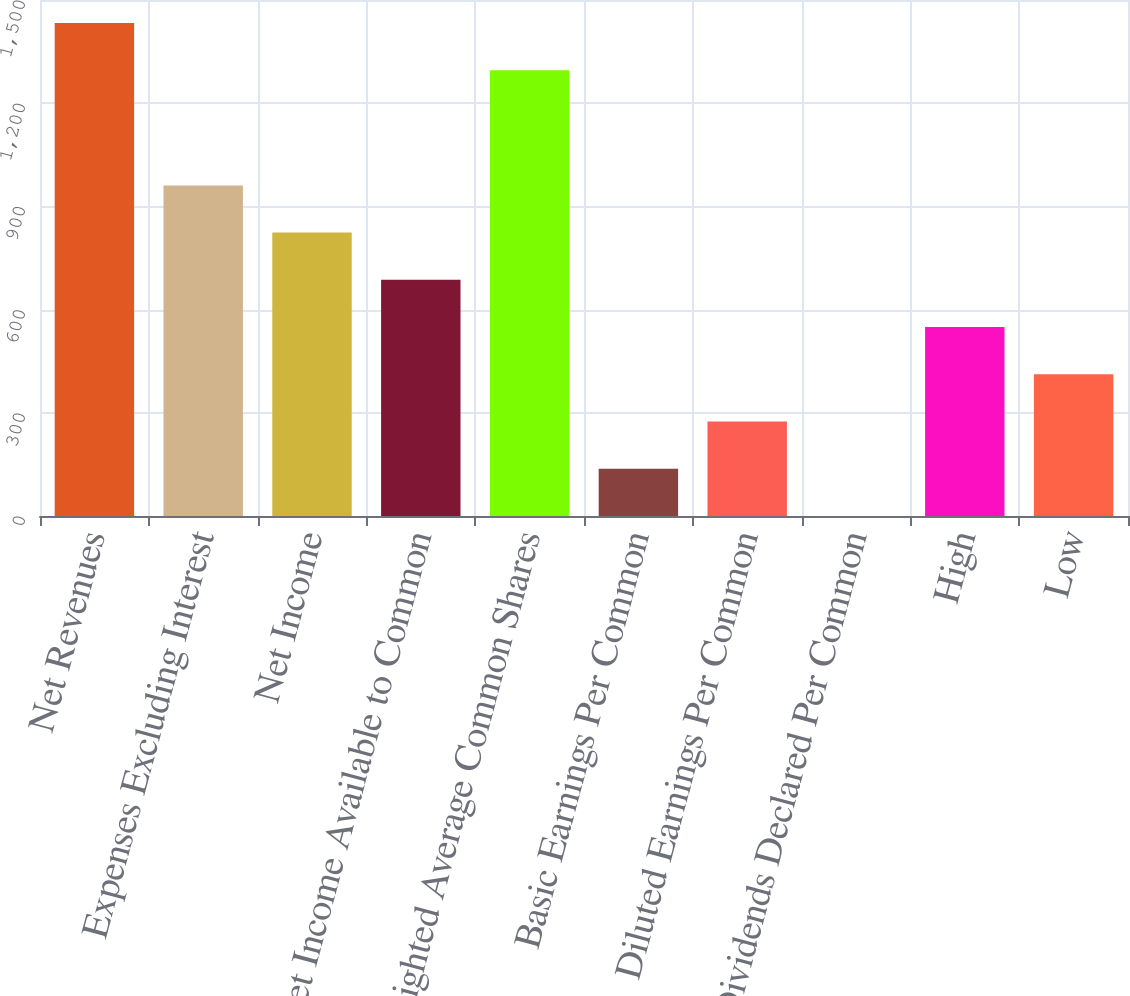Convert chart to OTSL. <chart><loc_0><loc_0><loc_500><loc_500><bar_chart><fcel>Net Revenues<fcel>Expenses Excluding Interest<fcel>Net Income<fcel>Net Income Available to Common<fcel>Weighted Average Common Shares<fcel>Basic Earnings Per Common<fcel>Diluted Earnings Per Common<fcel>Dividends Declared Per Common<fcel>High<fcel>Low<nl><fcel>1433.29<fcel>961.09<fcel>823.8<fcel>686.51<fcel>1296<fcel>137.35<fcel>274.64<fcel>0.06<fcel>549.22<fcel>411.93<nl></chart> 